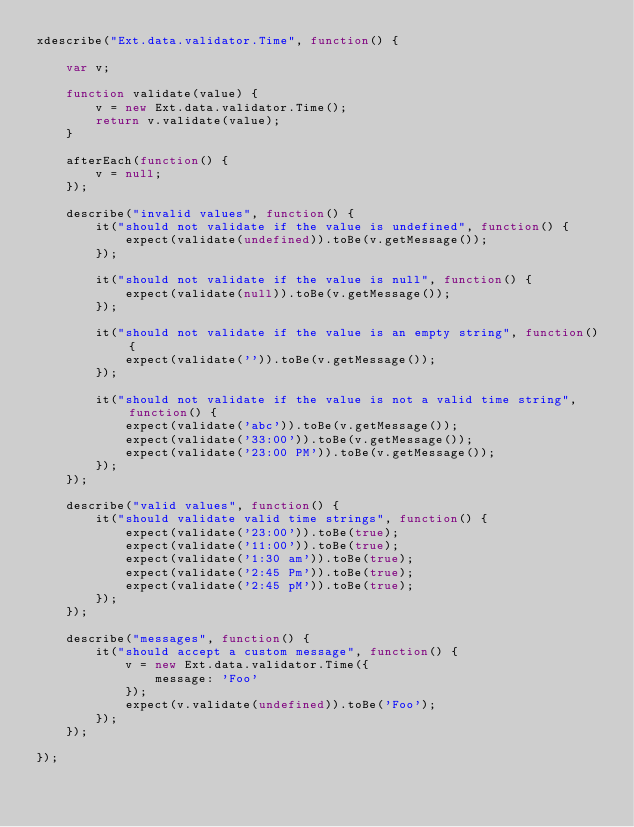Convert code to text. <code><loc_0><loc_0><loc_500><loc_500><_JavaScript_>xdescribe("Ext.data.validator.Time", function() {

    var v;

    function validate(value) {
        v = new Ext.data.validator.Time();
        return v.validate(value);
    }

    afterEach(function() {
        v = null;
    });

    describe("invalid values", function() {
        it("should not validate if the value is undefined", function() {
            expect(validate(undefined)).toBe(v.getMessage());
        });

        it("should not validate if the value is null", function() {
            expect(validate(null)).toBe(v.getMessage());
        });

        it("should not validate if the value is an empty string", function() {
            expect(validate('')).toBe(v.getMessage());
        });

        it("should not validate if the value is not a valid time string", function() {
            expect(validate('abc')).toBe(v.getMessage());
            expect(validate('33:00')).toBe(v.getMessage());
            expect(validate('23:00 PM')).toBe(v.getMessage());
        });
    });

    describe("valid values", function() {
        it("should validate valid time strings", function() {
            expect(validate('23:00')).toBe(true);
            expect(validate('11:00')).toBe(true);
            expect(validate('1:30 am')).toBe(true);
            expect(validate('2:45 Pm')).toBe(true);
            expect(validate('2:45 pM')).toBe(true);
        });
    });

    describe("messages", function() {
        it("should accept a custom message", function() {
            v = new Ext.data.validator.Time({
                message: 'Foo'
            });
            expect(v.validate(undefined)).toBe('Foo');
        });
    });

});
</code> 